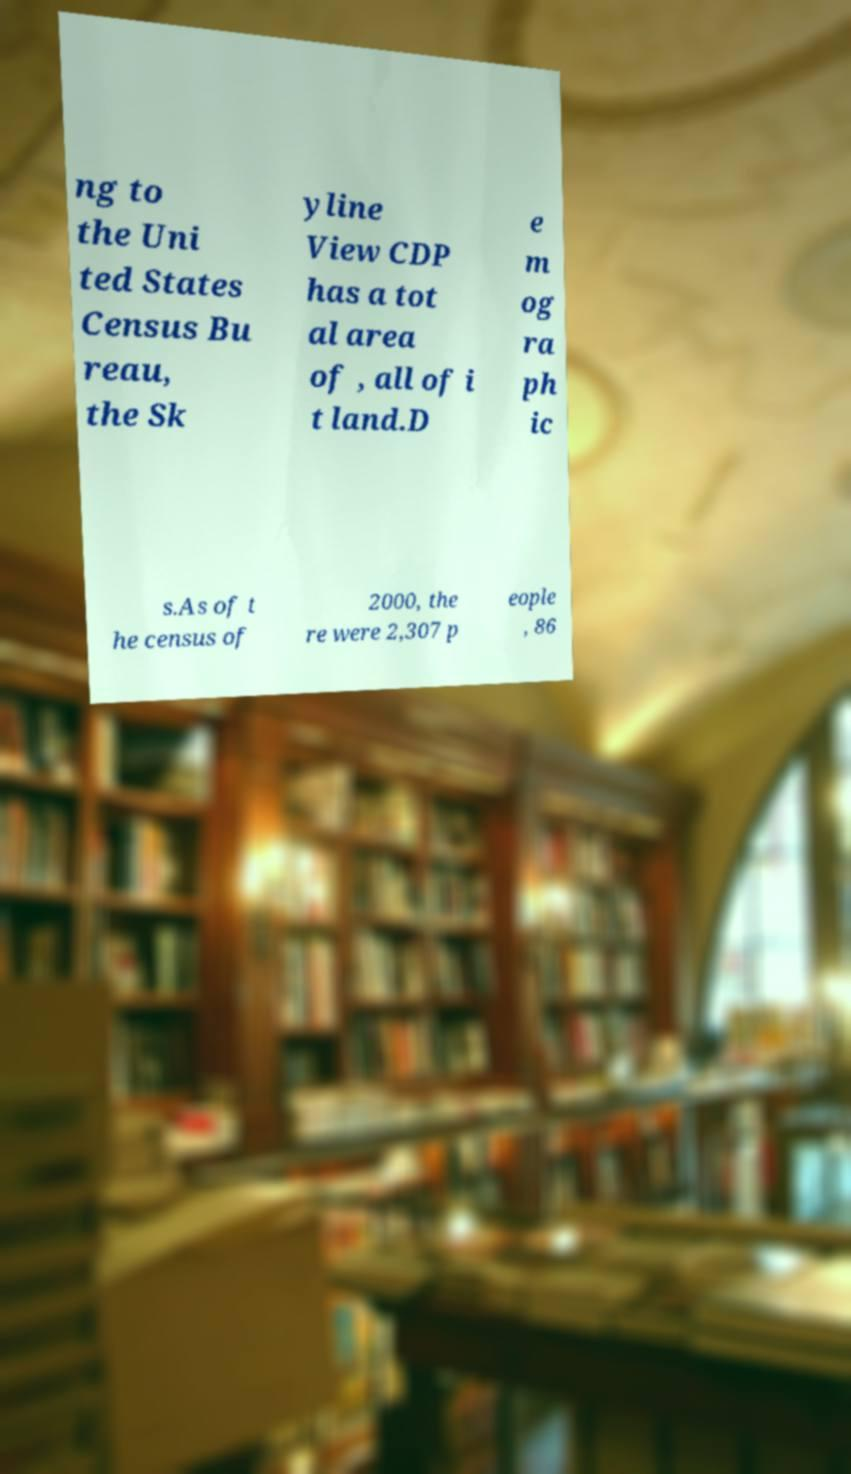For documentation purposes, I need the text within this image transcribed. Could you provide that? ng to the Uni ted States Census Bu reau, the Sk yline View CDP has a tot al area of , all of i t land.D e m og ra ph ic s.As of t he census of 2000, the re were 2,307 p eople , 86 